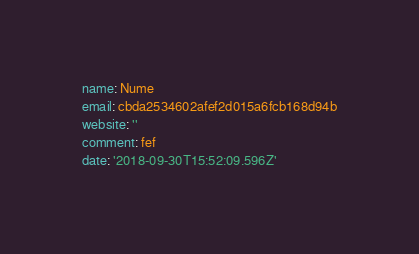<code> <loc_0><loc_0><loc_500><loc_500><_YAML_>name: Nume
email: cbda2534602afef2d015a6fcb168d94b
website: ''
comment: fef
date: '2018-09-30T15:52:09.596Z'
</code> 